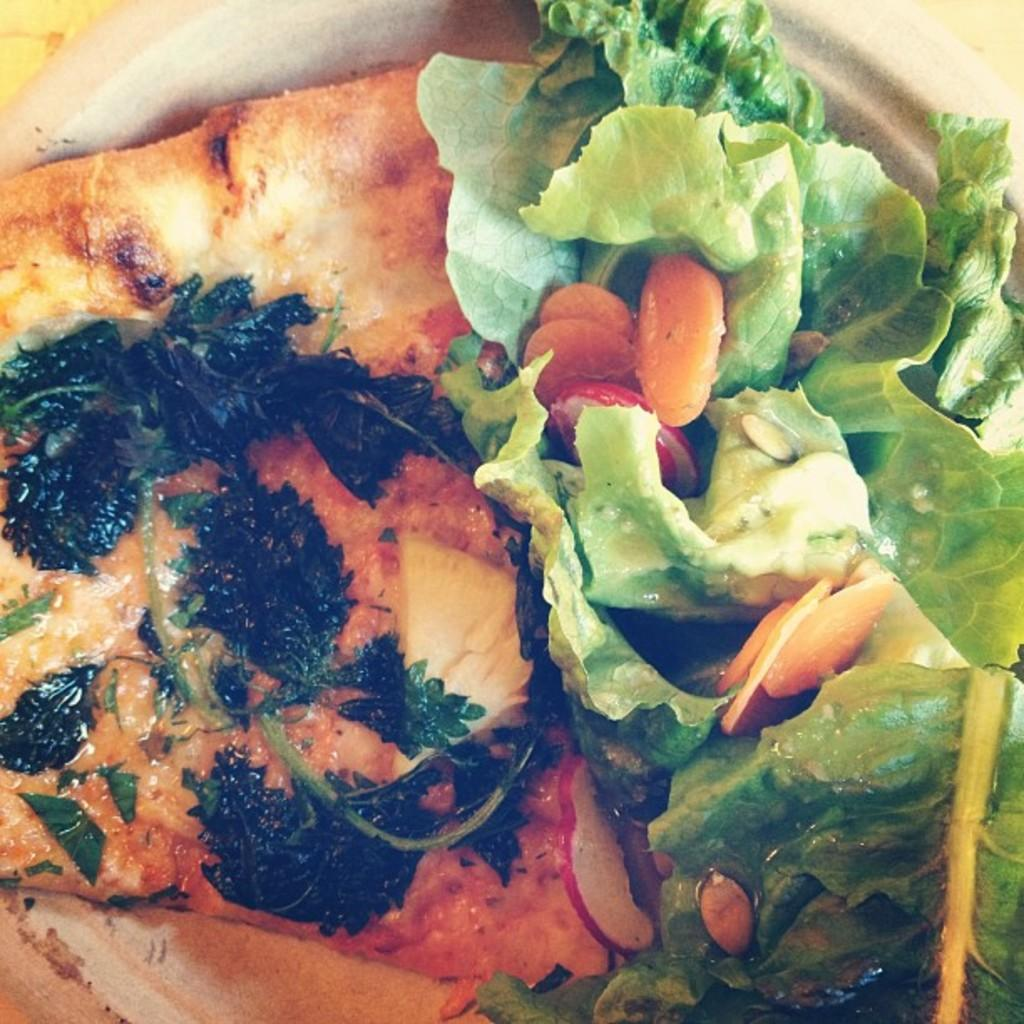What is present on the plate in the image? There are food items on the plate in the image. Can you describe the food items on the plate? Unfortunately, the specific food items cannot be determined from the provided facts. Where is the scarecrow located in the image? There is no scarecrow present in the image. Is the food on the plate hot or cold? The temperature of the food cannot be determined from the provided facts. 